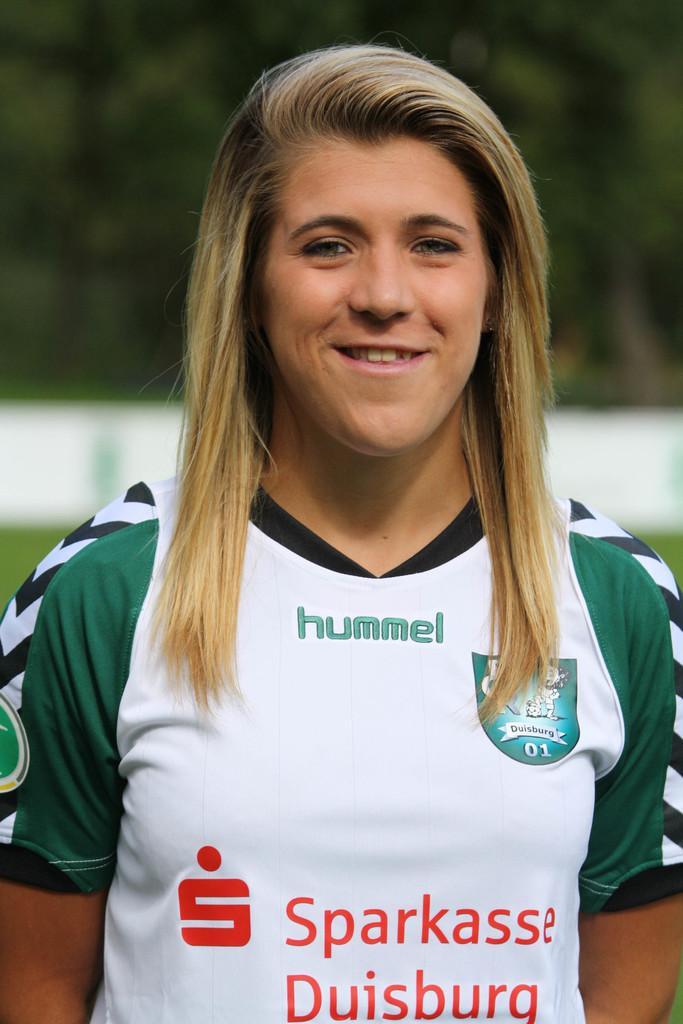What number is shown on the shield?
Make the answer very short. 01. Who sponsors the players?
Provide a short and direct response. Hummel. 